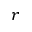Convert formula to latex. <formula><loc_0><loc_0><loc_500><loc_500>r</formula> 